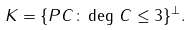<formula> <loc_0><loc_0><loc_500><loc_500>K = \{ P C \colon \deg \, C \leq 3 \} ^ { \perp } .</formula> 